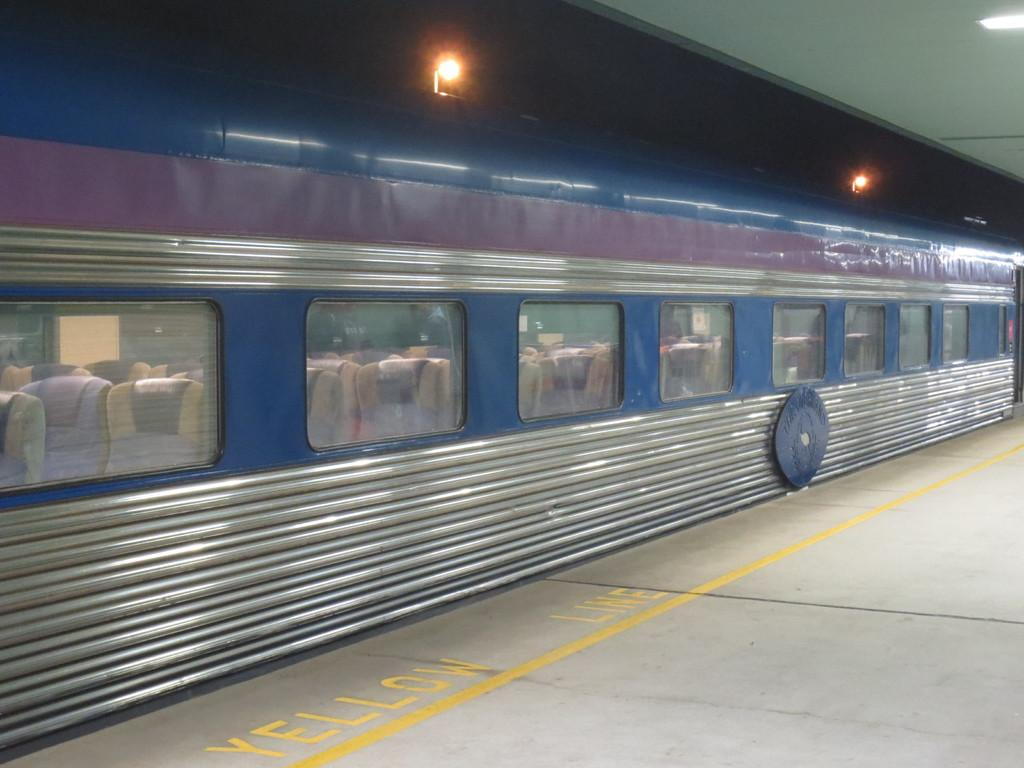What is the main subject of the image? The main subject of the image is a train. What can be seen inside the train through the glass? Chairs are visible through the glass in the train. What other elements are present in the image besides the train? There are lights and a platform visible in the image. Can you tell me how many chess pieces are on the platform in the image? There is no chess set or pieces present on the platform in the image. What type of voyage is the train taking in the image? The image does not provide information about the train's destination or purpose, so it cannot be determined if it is on a voyage. 